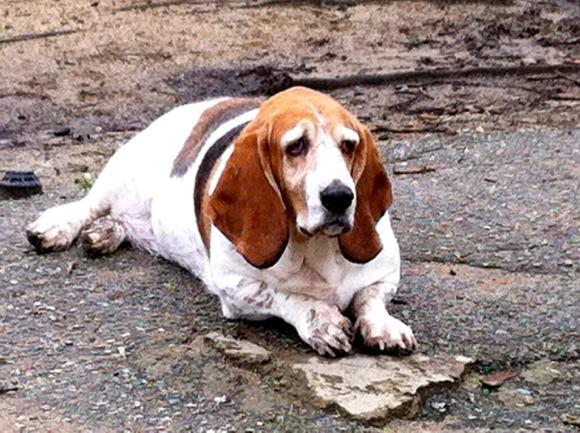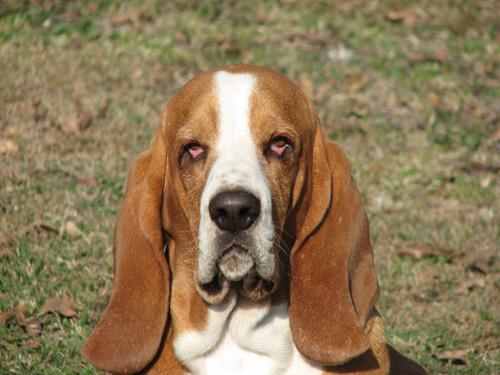The first image is the image on the left, the second image is the image on the right. Analyze the images presented: Is the assertion "In one of the images two mammals can be seen wearing hats." valid? Answer yes or no. No. The first image is the image on the left, the second image is the image on the right. Evaluate the accuracy of this statement regarding the images: "One image with at least one camera-facing basset hound in it also contains two hats.". Is it true? Answer yes or no. No. 